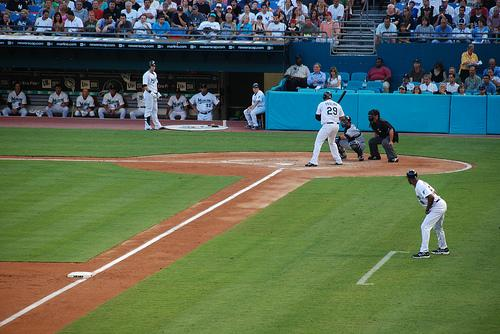What color are the lines in the image and what is their approximate location? The lines are white and are mainly located around the baseball field with x-coordinates ranging from 48 to 364 and y-coordinates from 232 to 271. What is the predominant element near the top of the image with the x-coordinate between 300 and 400? Numerous baseball players are found near the top of the image with x-coordinates ranging from 301 to 401, wearing uniforms and participating in the game. Identify the primary subject in the image and describe their appearance and activity. A baseball player in a uniform is in the image, with various white lines and objects surrounding them on the field. What is the purpose of the white lines on the image? The white lines painted on the grass serve as markers, boundaries, or indicators for certain areas in the baseball field. Whom can we find behind home plate and what is their role in baseball? An umpire crouched behind home plate, responsible for making decisions such as balls, strikes, and outs in a baseball game. Explain the main elements of the image relating to a baseball game. The image includes a baseball player in a uniform, a batter at the plate, the third base coach, the third base pad, a batter standing on deck, an umpire crouched behind home plate, and a baseball bullpen. 